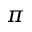<formula> <loc_0><loc_0><loc_500><loc_500>\pi</formula> 